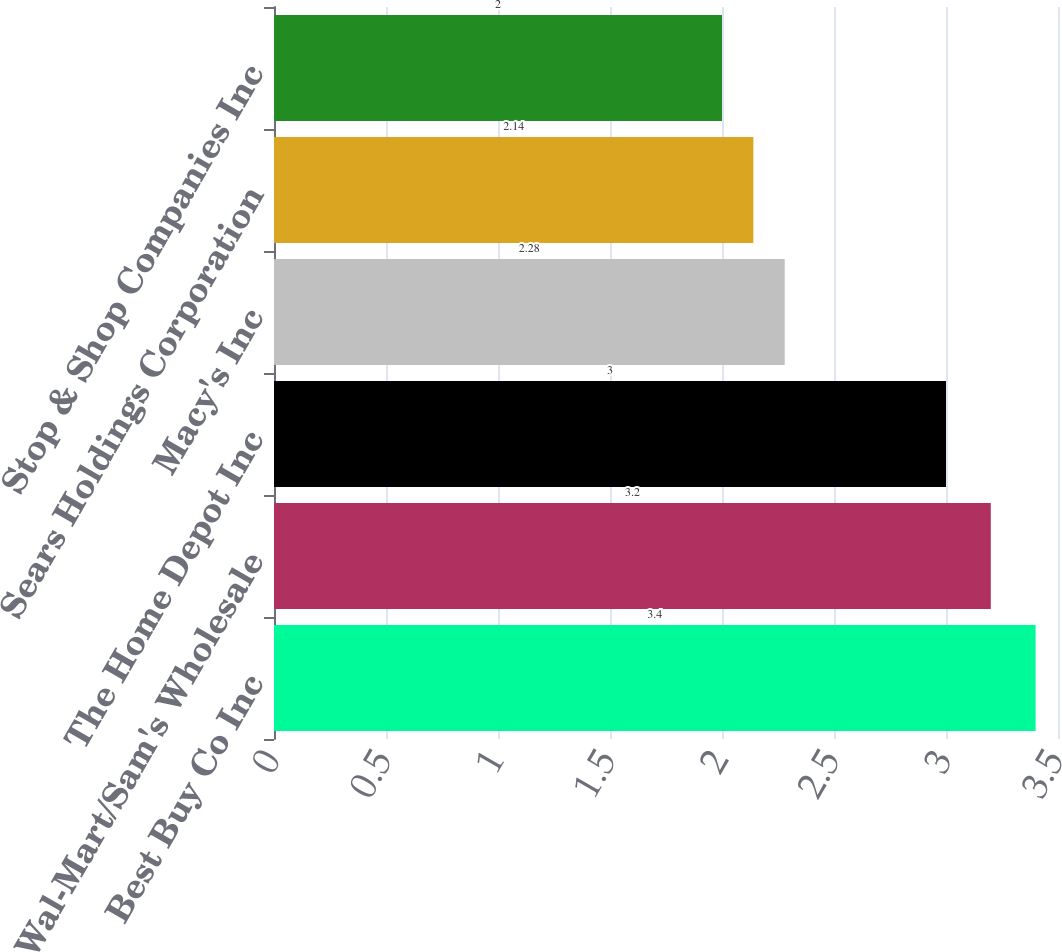Convert chart. <chart><loc_0><loc_0><loc_500><loc_500><bar_chart><fcel>Best Buy Co Inc<fcel>Wal-Mart/Sam's Wholesale<fcel>The Home Depot Inc<fcel>Macy's Inc<fcel>Sears Holdings Corporation<fcel>Stop & Shop Companies Inc<nl><fcel>3.4<fcel>3.2<fcel>3<fcel>2.28<fcel>2.14<fcel>2<nl></chart> 